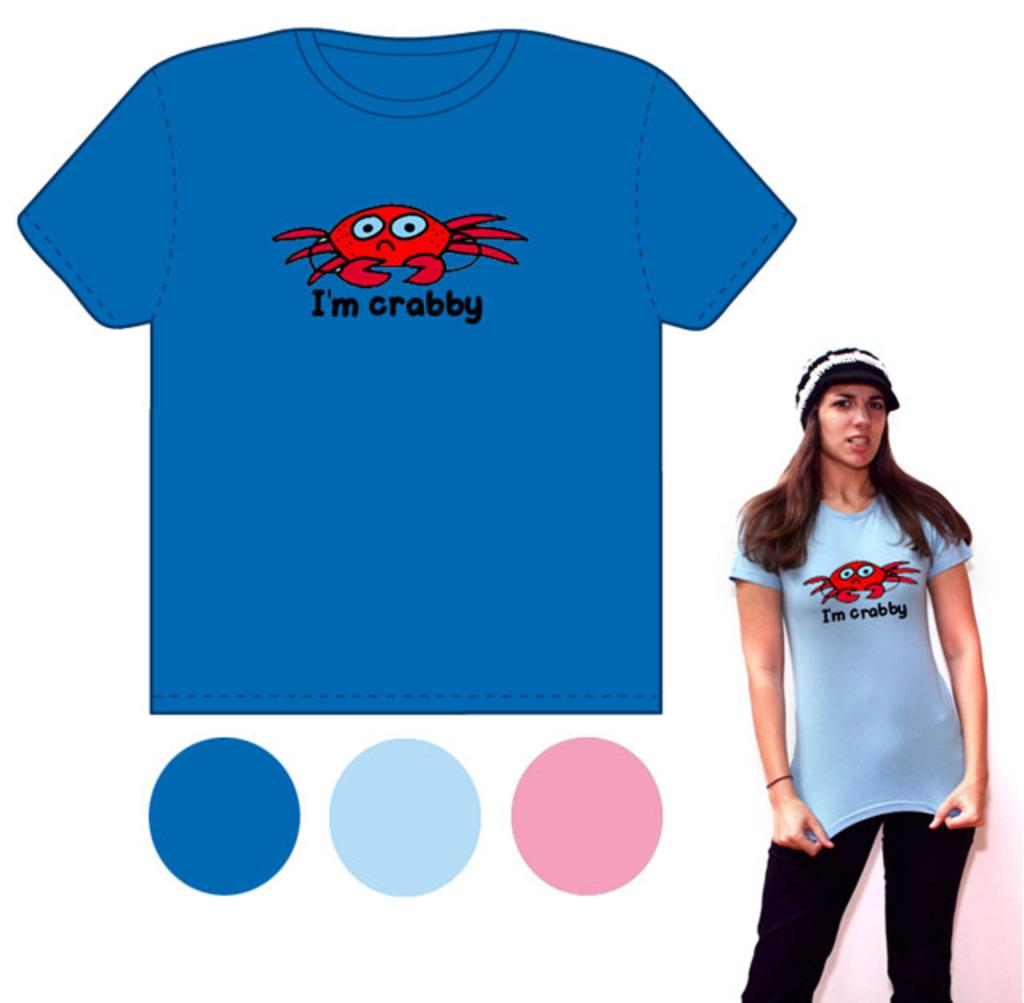<image>
Summarize the visual content of the image. A woman is modeling a blue shirt with the phrase I'm crabby on it. 